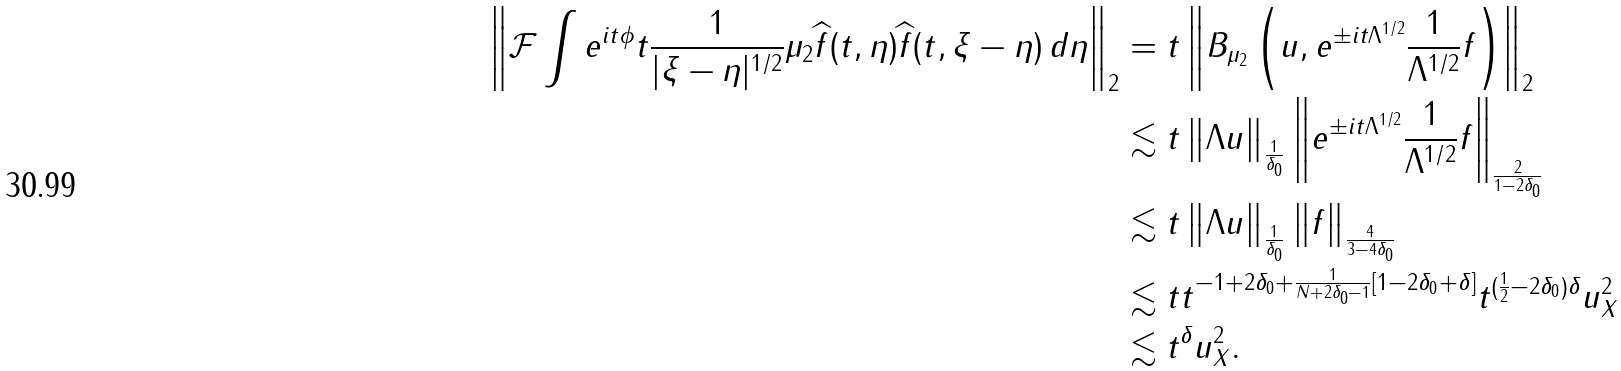Convert formula to latex. <formula><loc_0><loc_0><loc_500><loc_500>\left \| \mathcal { F } \int e ^ { i t \phi } t \frac { 1 } { | \xi - \eta | ^ { 1 / 2 } } \mu _ { 2 } \widehat { f } ( t , \eta ) \widehat { f } ( t , \xi - \eta ) \, d \eta \right \| _ { 2 } & = t \left \| B _ { \mu _ { 2 } } \left ( u , e ^ { \pm i t { \Lambda ^ { 1 / 2 } } } \frac { 1 } { \Lambda ^ { 1 / 2 } } f \right ) \right \| _ { 2 } \\ & \lesssim t \left \| \Lambda u \right \| _ { \frac { 1 } { \delta _ { 0 } } } \left \| e ^ { \pm i t { \Lambda ^ { 1 / 2 } } } \frac { 1 } { \Lambda ^ { 1 / 2 } } f \right \| _ { \frac { 2 } { 1 - 2 \delta _ { 0 } } } \\ & \lesssim t \left \| \Lambda u \right \| _ { \frac { 1 } { \delta _ { 0 } } } \left \| f \right \| _ { \frac { 4 } { 3 - 4 \delta _ { 0 } } } \\ & \lesssim t t ^ { - 1 + 2 \delta _ { 0 } + \frac { 1 } { N + 2 \delta _ { 0 } - 1 } \left [ 1 - 2 \delta _ { 0 } + \delta \right ] } t ^ { ( \frac { 1 } { 2 } - 2 \delta _ { 0 } ) \delta } \| u \| ^ { 2 } _ { X } \\ & \lesssim t ^ { \delta } \| u \| ^ { 2 } _ { X } .</formula> 